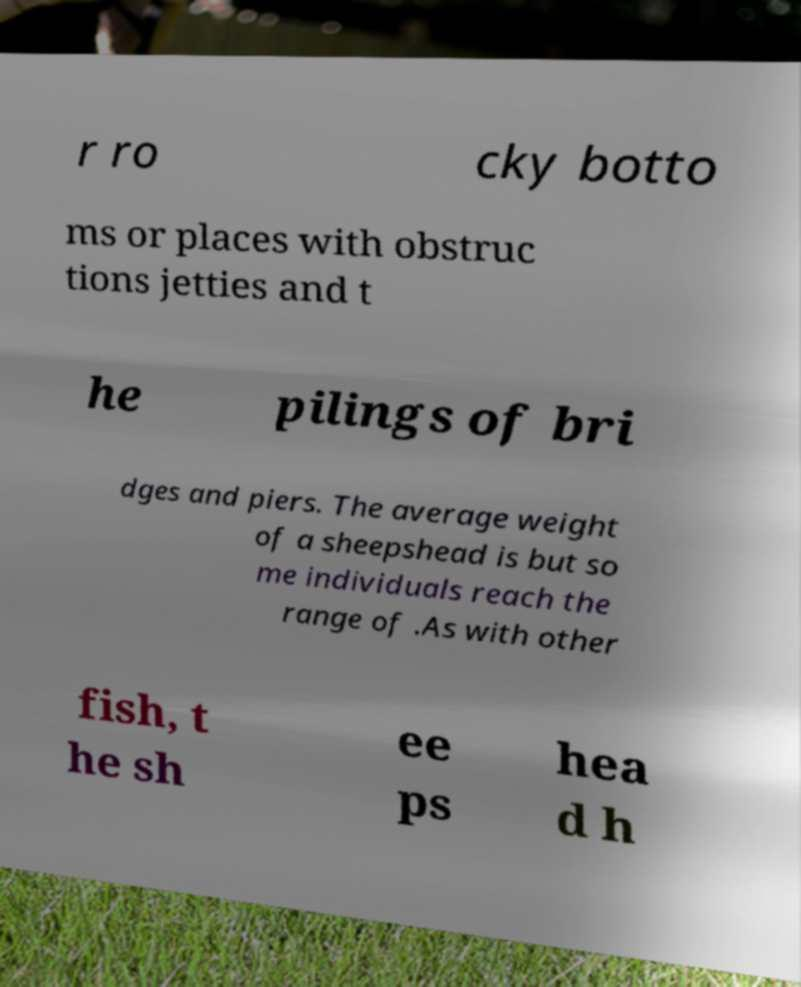What messages or text are displayed in this image? I need them in a readable, typed format. r ro cky botto ms or places with obstruc tions jetties and t he pilings of bri dges and piers. The average weight of a sheepshead is but so me individuals reach the range of .As with other fish, t he sh ee ps hea d h 